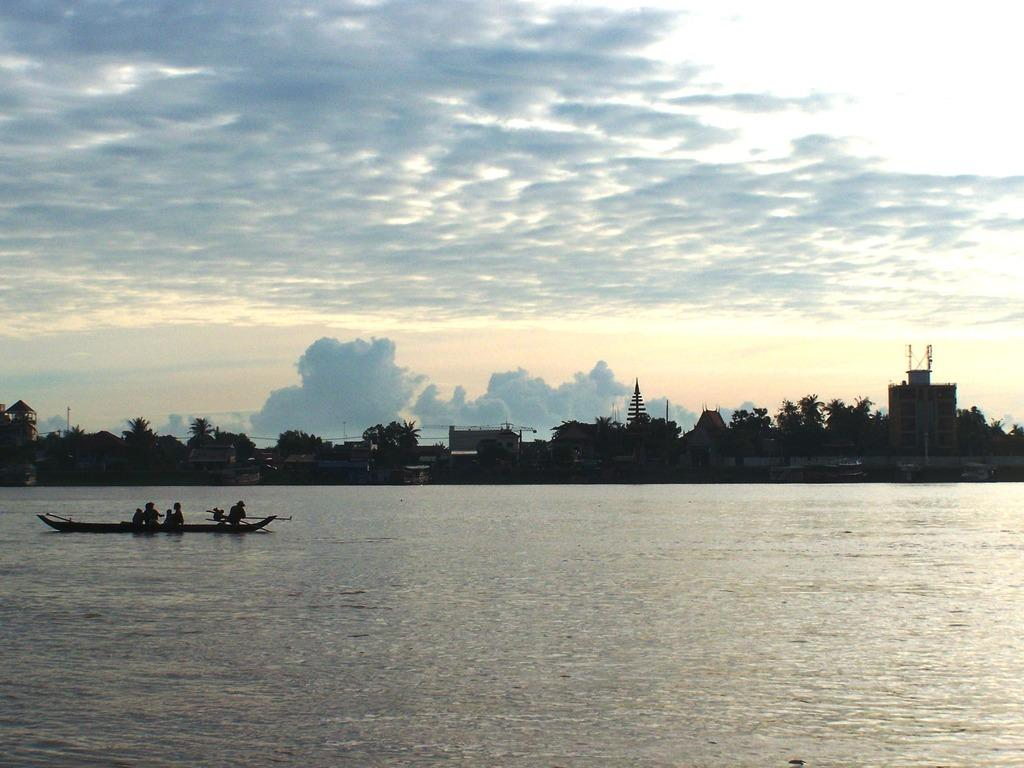What is the main subject of the image? The main subject of the image is water. What is on the water in the image? There is a boat on the water in the image. What are the people on the boat doing? People are sitting on the boat. What can be seen in the background of the image? There are trees, buildings, and the sky visible in the background of the image. What type of juice can be seen being squeezed from the button in the image? There is no button or juice present in the image. What treatment is being administered to the trees in the background of the image? There is no treatment being administered to the trees in the image; they are simply visible in the background. 